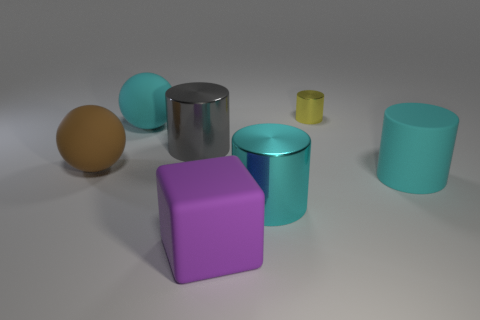Is there anything else that has the same size as the yellow cylinder?
Offer a very short reply. No. What size is the gray metal object that is the same shape as the cyan metal thing?
Offer a very short reply. Large. What color is the large cylinder that is both behind the large cyan shiny cylinder and on the left side of the rubber cylinder?
Offer a very short reply. Gray. Do the gray object and the cylinder behind the large gray metallic cylinder have the same material?
Provide a succinct answer. Yes. Are there fewer small metallic objects that are behind the purple matte object than large purple rubber things?
Provide a short and direct response. No. What number of other things are the same shape as the big purple matte object?
Your response must be concise. 0. Is there any other thing that is the same color as the tiny metallic thing?
Your response must be concise. No. Do the large matte cylinder and the big rubber object that is behind the big brown rubber sphere have the same color?
Offer a very short reply. Yes. What number of other things are there of the same size as the cyan sphere?
Your answer should be compact. 5. What number of blocks are either shiny objects or large shiny objects?
Ensure brevity in your answer.  0. 